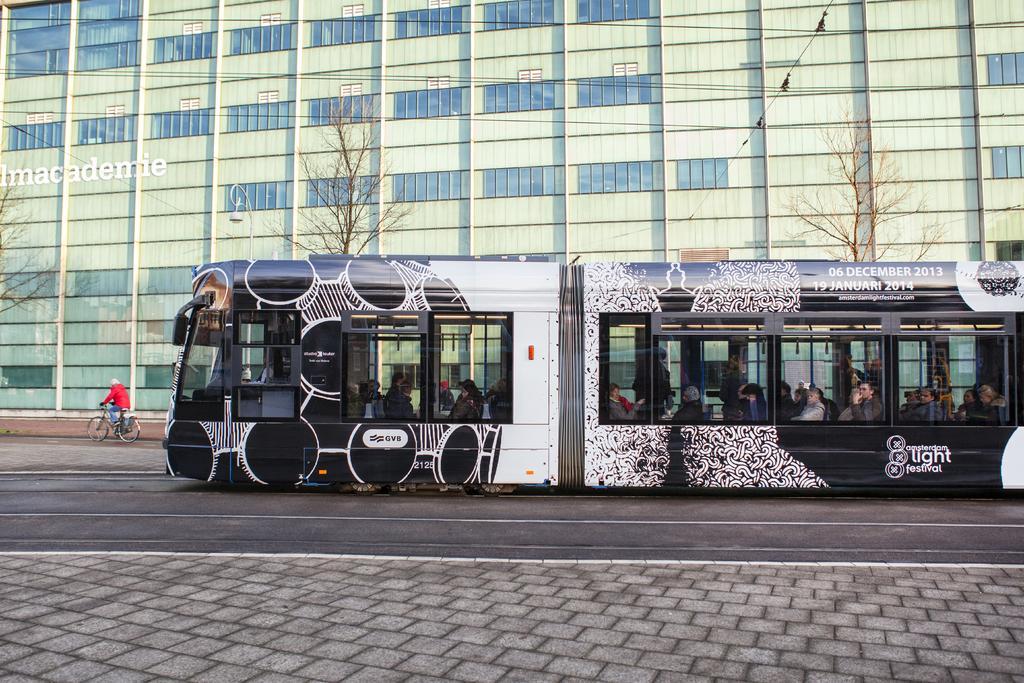Can you describe this image briefly? In this image in the center there is one bus, and in the bus there are some people who are sitting. At the bottom there is a road and footpath and on the left side there is one person who is sitting on a cycle and riding, and also we could see some trees. In the background there is a building. 